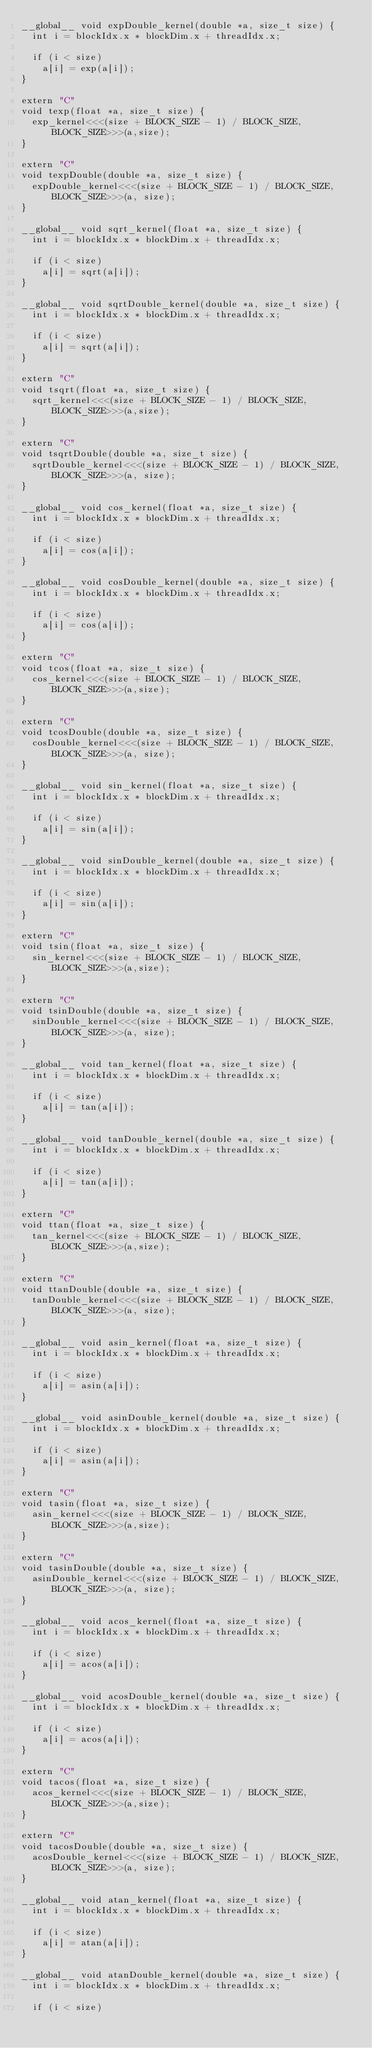<code> <loc_0><loc_0><loc_500><loc_500><_Cuda_>__global__ void expDouble_kernel(double *a, size_t size) {
  int i = blockIdx.x * blockDim.x + threadIdx.x;

  if (i < size)
    a[i] = exp(a[i]);
}

extern "C"
void texp(float *a, size_t size) {
  exp_kernel<<<(size + BLOCK_SIZE - 1) / BLOCK_SIZE, BLOCK_SIZE>>>(a,size);
}

extern "C"
void texpDouble(double *a, size_t size) {
  expDouble_kernel<<<(size + BLOCK_SIZE - 1) / BLOCK_SIZE, BLOCK_SIZE>>>(a, size);
}

__global__ void sqrt_kernel(float *a, size_t size) {
  int i = blockIdx.x * blockDim.x + threadIdx.x;

  if (i < size)
    a[i] = sqrt(a[i]);
}

__global__ void sqrtDouble_kernel(double *a, size_t size) {
  int i = blockIdx.x * blockDim.x + threadIdx.x;

  if (i < size)
    a[i] = sqrt(a[i]);
}

extern "C"
void tsqrt(float *a, size_t size) {
  sqrt_kernel<<<(size + BLOCK_SIZE - 1) / BLOCK_SIZE, BLOCK_SIZE>>>(a,size);
}

extern "C"
void tsqrtDouble(double *a, size_t size) {
  sqrtDouble_kernel<<<(size + BLOCK_SIZE - 1) / BLOCK_SIZE, BLOCK_SIZE>>>(a, size);
}

__global__ void cos_kernel(float *a, size_t size) {
  int i = blockIdx.x * blockDim.x + threadIdx.x;

  if (i < size)
    a[i] = cos(a[i]);
}

__global__ void cosDouble_kernel(double *a, size_t size) {
  int i = blockIdx.x * blockDim.x + threadIdx.x;

  if (i < size)
    a[i] = cos(a[i]);
}

extern "C"
void tcos(float *a, size_t size) {
  cos_kernel<<<(size + BLOCK_SIZE - 1) / BLOCK_SIZE, BLOCK_SIZE>>>(a,size);
}

extern "C"
void tcosDouble(double *a, size_t size) {
  cosDouble_kernel<<<(size + BLOCK_SIZE - 1) / BLOCK_SIZE, BLOCK_SIZE>>>(a, size);
}

__global__ void sin_kernel(float *a, size_t size) {
  int i = blockIdx.x * blockDim.x + threadIdx.x;

  if (i < size)
    a[i] = sin(a[i]);
}

__global__ void sinDouble_kernel(double *a, size_t size) {
  int i = blockIdx.x * blockDim.x + threadIdx.x;

  if (i < size)
    a[i] = sin(a[i]);
}

extern "C"
void tsin(float *a, size_t size) {
  sin_kernel<<<(size + BLOCK_SIZE - 1) / BLOCK_SIZE, BLOCK_SIZE>>>(a,size);
}

extern "C"
void tsinDouble(double *a, size_t size) {
  sinDouble_kernel<<<(size + BLOCK_SIZE - 1) / BLOCK_SIZE, BLOCK_SIZE>>>(a, size);
}

__global__ void tan_kernel(float *a, size_t size) {
  int i = blockIdx.x * blockDim.x + threadIdx.x;

  if (i < size)
    a[i] = tan(a[i]);
}

__global__ void tanDouble_kernel(double *a, size_t size) {
  int i = blockIdx.x * blockDim.x + threadIdx.x;

  if (i < size)
    a[i] = tan(a[i]);
}

extern "C"
void ttan(float *a, size_t size) {
  tan_kernel<<<(size + BLOCK_SIZE - 1) / BLOCK_SIZE, BLOCK_SIZE>>>(a,size);
}

extern "C"
void ttanDouble(double *a, size_t size) {
  tanDouble_kernel<<<(size + BLOCK_SIZE - 1) / BLOCK_SIZE, BLOCK_SIZE>>>(a, size);
}

__global__ void asin_kernel(float *a, size_t size) {
  int i = blockIdx.x * blockDim.x + threadIdx.x;

  if (i < size)
    a[i] = asin(a[i]);
}

__global__ void asinDouble_kernel(double *a, size_t size) {
  int i = blockIdx.x * blockDim.x + threadIdx.x;

  if (i < size)
    a[i] = asin(a[i]);
}

extern "C"
void tasin(float *a, size_t size) {
  asin_kernel<<<(size + BLOCK_SIZE - 1) / BLOCK_SIZE, BLOCK_SIZE>>>(a,size);
}

extern "C"
void tasinDouble(double *a, size_t size) {
  asinDouble_kernel<<<(size + BLOCK_SIZE - 1) / BLOCK_SIZE, BLOCK_SIZE>>>(a, size);
}

__global__ void acos_kernel(float *a, size_t size) {
  int i = blockIdx.x * blockDim.x + threadIdx.x;

  if (i < size)
    a[i] = acos(a[i]);
}

__global__ void acosDouble_kernel(double *a, size_t size) {
  int i = blockIdx.x * blockDim.x + threadIdx.x;

  if (i < size)
    a[i] = acos(a[i]);
}

extern "C"
void tacos(float *a, size_t size) {
  acos_kernel<<<(size + BLOCK_SIZE - 1) / BLOCK_SIZE, BLOCK_SIZE>>>(a,size);
}

extern "C"
void tacosDouble(double *a, size_t size) {
  acosDouble_kernel<<<(size + BLOCK_SIZE - 1) / BLOCK_SIZE, BLOCK_SIZE>>>(a, size);
}

__global__ void atan_kernel(float *a, size_t size) {
  int i = blockIdx.x * blockDim.x + threadIdx.x;

  if (i < size)
    a[i] = atan(a[i]);
}

__global__ void atanDouble_kernel(double *a, size_t size) {
  int i = blockIdx.x * blockDim.x + threadIdx.x;

  if (i < size)</code> 